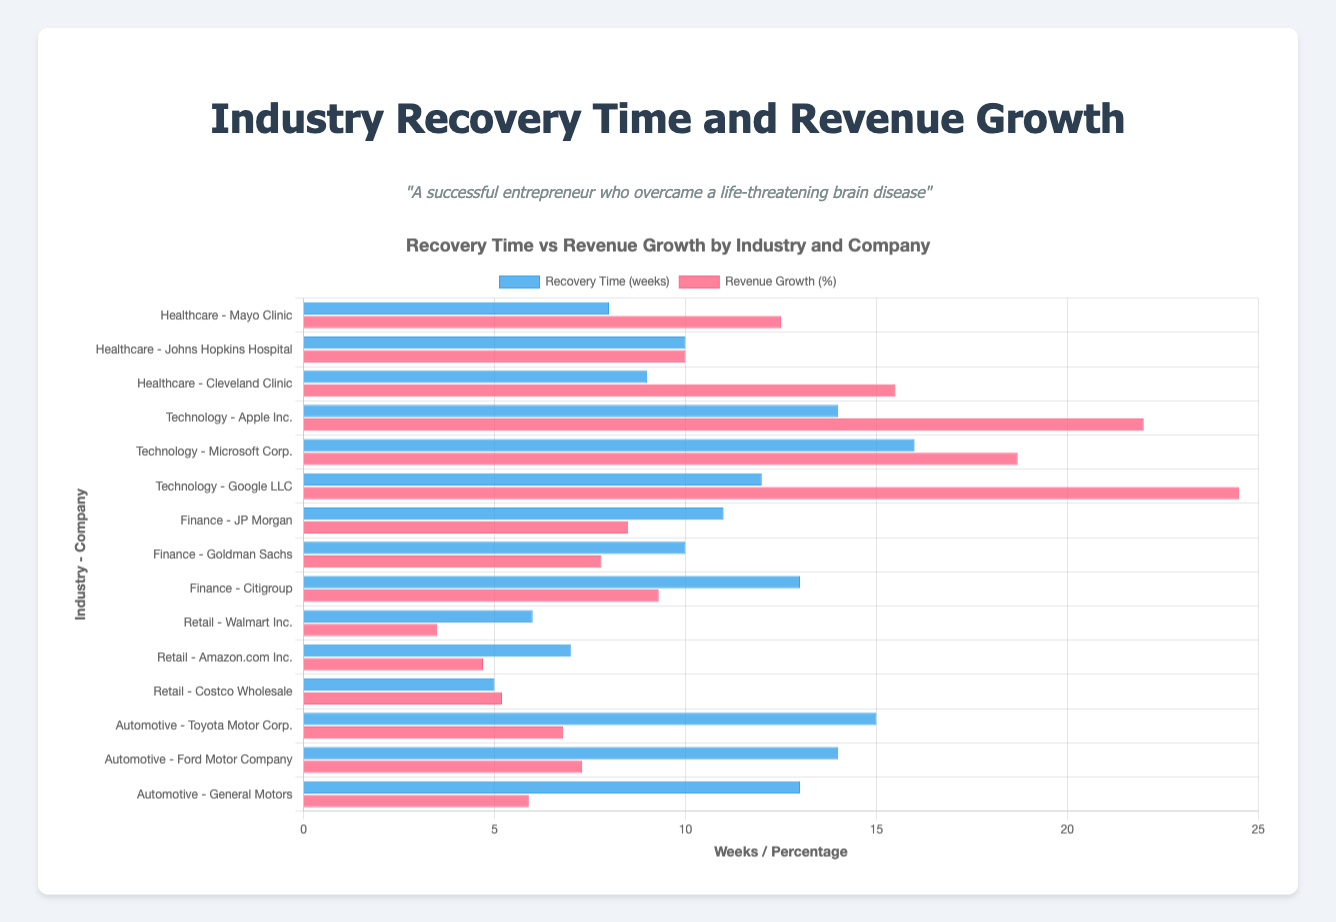What's the average recovery time for companies in the Healthcare industry? Sum the recovery times for Mayo Clinic (8 weeks), Johns Hopkins Hospital (10 weeks), and Cleveland Clinic (9 weeks), which totals 27 weeks. Then, divide by the number of entities, which is 3. So, 27/3 = 9 weeks.
Answer: 9 weeks Which industry has the entity with the highest revenue growth percentage? The highest revenue growth percentage is 24.5%, which belongs to Google LLC in the Technology industry.
Answer: Technology What is the difference between the recovery times of Ford Motor Company and General Motors? Ford Motor Company has a recovery time of 14 weeks, and General Motors has 13 weeks. Subtract General Motors' recovery time from Ford's: 14 - 13 = 1 week.
Answer: 1 week Which company in the Retail industry has the shortest recovery time? In the Retail industry, the recovery times are Costco Wholesale (5 weeks), Walmart Inc. (6 weeks), and Amazon.com Inc. (7 weeks). The shortest recovery time is 5 weeks, which belongs to Costco Wholesale.
Answer: Costco Wholesale Between Mayo Clinic and Apple Inc., which company has a higher revenue growth percentage and by how much? Mayo Clinic has a revenue growth percentage of 12.5%, while Apple Inc. has 22.0%. Subtract Mayo Clinic's percentage from Apple's: 22.0 - 12.5 = 9.5%.
Answer: Apple Inc. by 9.5% What is the sum of revenue growth percentages for all companies in the Finance industry? The revenue growth percentages for JP Morgan (8.5%), Goldman Sachs (7.8%), and Citigroup (9.3%) sum up to 8.5 + 7.8 + 9.3 = 25.6%.
Answer: 25.6% How does Toyota Motor Corp.'s revenue growth percentage compare to that of Cleveland Clinic? Toyota Motor Corp.'s revenue growth percentage is 6.8%, and Cleveland Clinic's is 15.5%. Therefore, Cleveland Clinic's revenue growth is higher.
Answer: Cleveland Clinic is higher Among Walmart Inc., Amazon.com Inc., and Costco Wholesale, which company has the highest revenue growth percentage? Walmart Inc. has a revenue growth percentage of 3.5%, Amazon.com Inc. has 4.7%, and Costco Wholesale has 5.2%. The highest is Costco Wholesale at 5.2%.
Answer: Costco Wholesale What is the average revenue growth percentage for the Technology industry? The revenue growth percentages for Apple Inc. (22.0%), Microsoft Corp. (18.7%), and Google LLC (24.5%) total 65.2%. Divide by 3 entities: 65.2 / 3 = 21.73%.
Answer: 21.73% Which company in the Healthcare industry has the longest recovery time, and how does it compare to the shortest recovery time in the Retail industry? Johns Hopkins Hospital in Healthcare has the longest recovery time of 10 weeks, and Costco Wholesale in Retail has the shortest recovery time of 5 weeks. The difference is 10 - 5 = 5 weeks.
Answer: Johns Hopkins Hospital, 5 weeks 